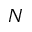Convert formula to latex. <formula><loc_0><loc_0><loc_500><loc_500>N</formula> 